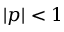<formula> <loc_0><loc_0><loc_500><loc_500>| p | < 1</formula> 